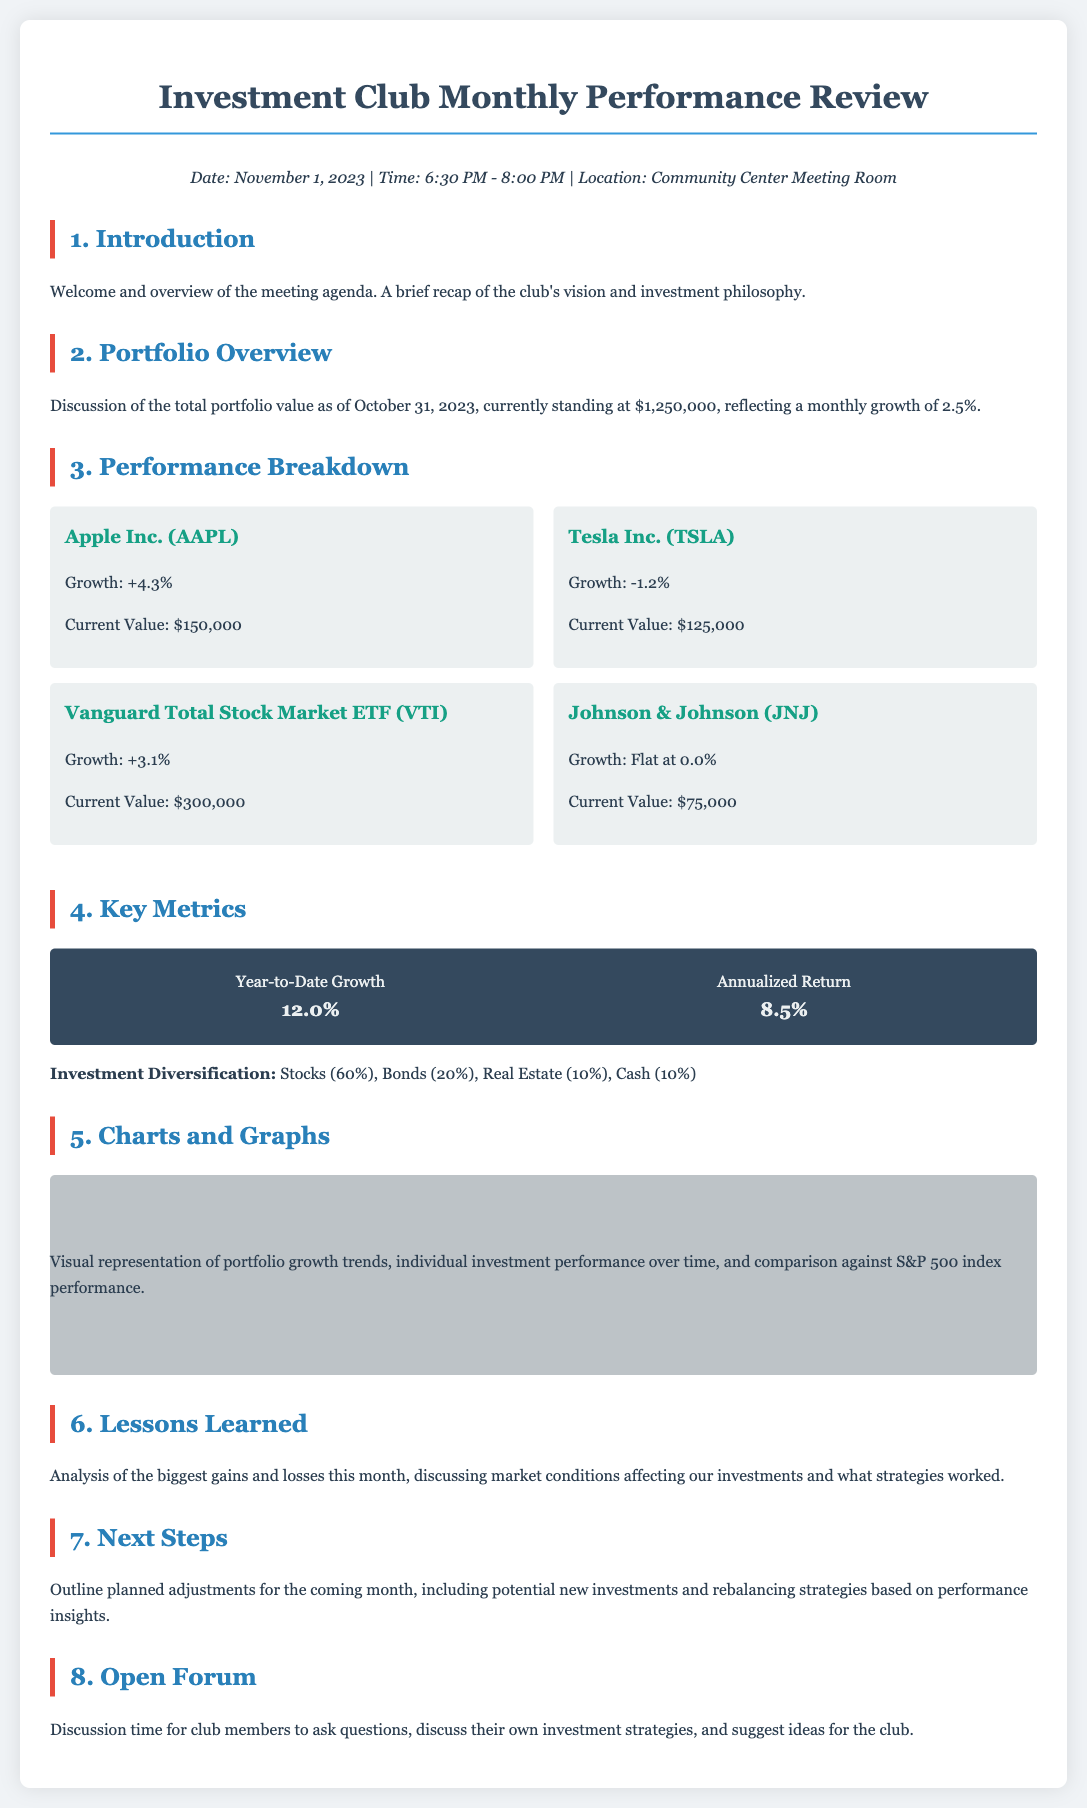What is the total portfolio value as of October 31, 2023? The total portfolio value is discussed in section 2 of the document.
Answer: $1,250,000 What was the monthly growth percentage for the portfolio? The monthly growth percentage is mentioned right after the total portfolio value in section 2.
Answer: 2.5% Which investment had the highest growth percentage? This information can be found in section 3 where each investment's growth is listed.
Answer: Apple Inc. (AAPL) What percentage of the portfolio is held in stocks? The investment diversification breakdown is provided in section 4.
Answer: 60% What is the current value of Johnson & Johnson (JNJ)? The current value can be found in section 3 under the performance breakdown for JNJ.
Answer: $75,000 What was the year-to-date growth percentage? This key metric is provided in section 4, and it summarizes performance.
Answer: 12.0% How long is the meeting scheduled for? The meeting duration is mentioned in the header info at the beginning of the document.
Answer: 1.5 hours What new investments are being considered in the next steps? The next steps involve potential investments, as indicated in section 7, though specific names aren't given.
Answer: Potential new investments What is the date of this performance review meeting? The date is listed in the header info at the top of the document.
Answer: November 1, 2023 